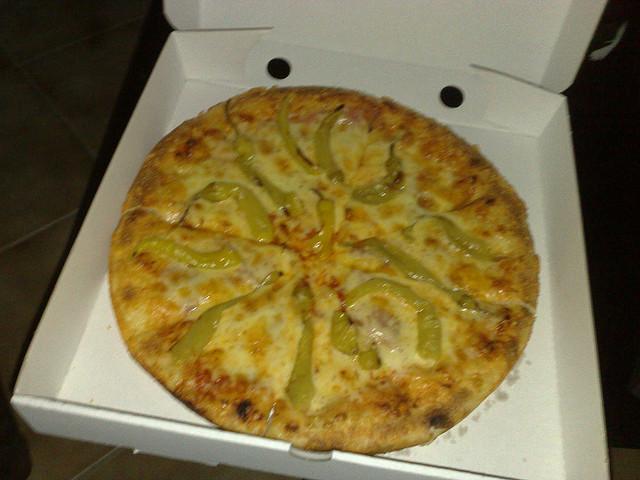Would a vegetarian eat this?
Short answer required. Yes. Has this pizza just been delivered?
Be succinct. Yes. Is cheese the only topping on this pizza?
Concise answer only. No. 